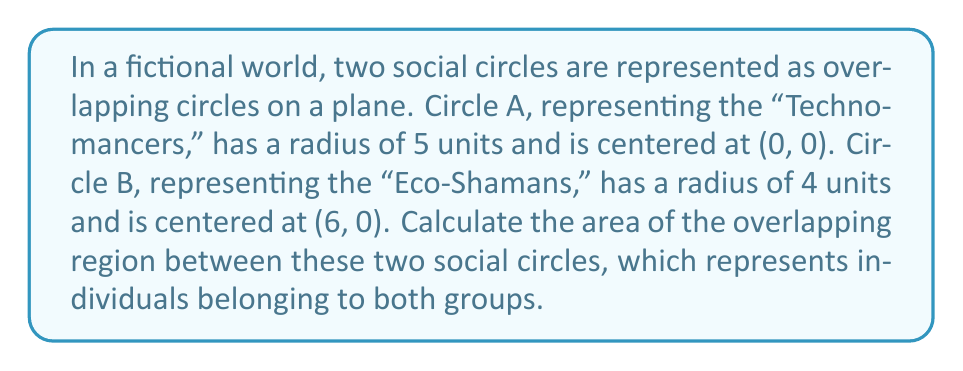Provide a solution to this math problem. Let's approach this step-by-step:

1) First, we need to find the distance between the centers of the two circles:
   $d = 6 - 0 = 6$ units

2) Now, we can use the formula for the area of intersection of two circles:

   $$A = r_1^2 \arccos(\frac{d^2 + r_1^2 - r_2^2}{2dr_1}) + r_2^2 \arccos(\frac{d^2 + r_2^2 - r_1^2}{2dr_2}) - \frac{1}{2}\sqrt{(-d+r_1+r_2)(d+r_1-r_2)(d-r_1+r_2)(d+r_1+r_2)}$$

   Where $r_1 = 5$, $r_2 = 4$, and $d = 6$

3) Let's calculate each part:

   Part 1: $5^2 \arccos(\frac{6^2 + 5^2 - 4^2}{2 \cdot 6 \cdot 5}) = 25 \arccos(\frac{61}{60}) \approx 3.490$

   Part 2: $4^2 \arccos(\frac{6^2 + 4^2 - 5^2}{2 \cdot 6 \cdot 4}) = 16 \arccos(\frac{11}{16}) \approx 8.257$

   Part 3: $\frac{1}{2}\sqrt{(-6+5+4)(6+5-4)(6-5+4)(6+5+4)} = \frac{1}{2}\sqrt{3 \cdot 7 \cdot 5 \cdot 15} \approx 9.530$

4) Putting it all together:

   $A = 3.490 + 8.257 - 9.530 \approx 2.217$

Therefore, the area of overlap between the two social circles is approximately 2.217 square units.
Answer: $2.217$ square units 